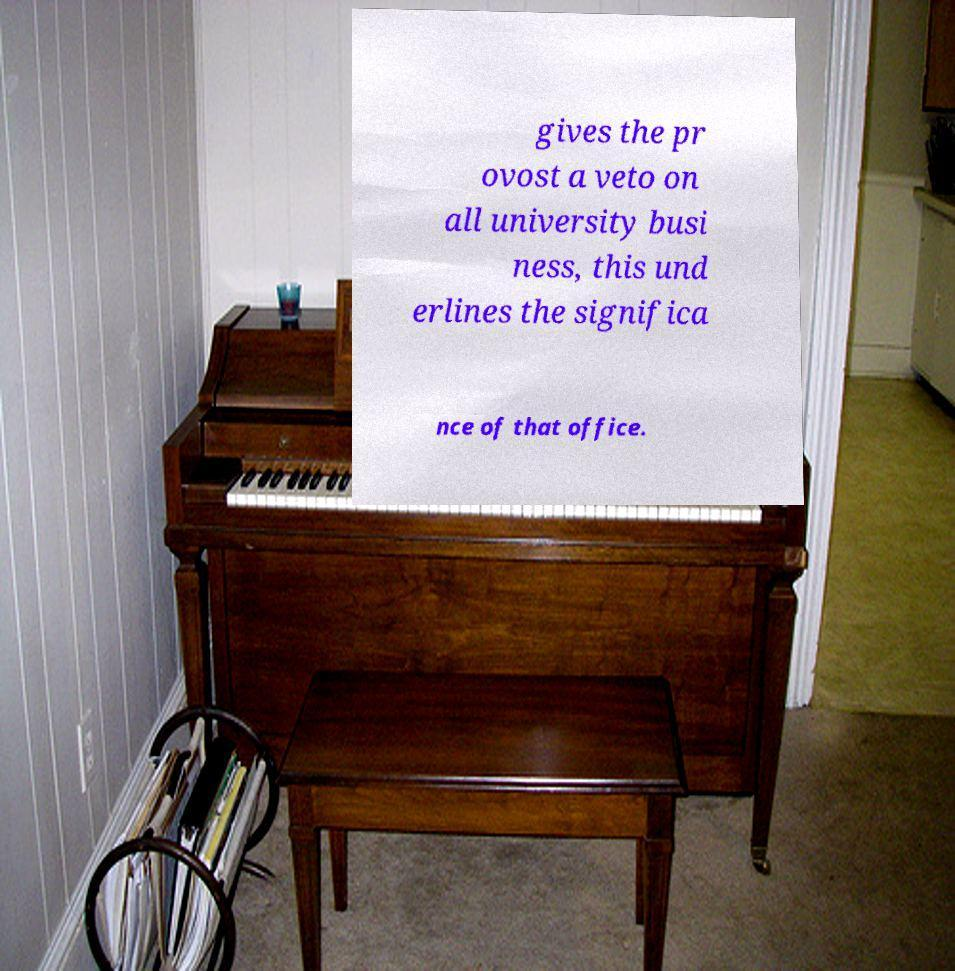Could you extract and type out the text from this image? gives the pr ovost a veto on all university busi ness, this und erlines the significa nce of that office. 